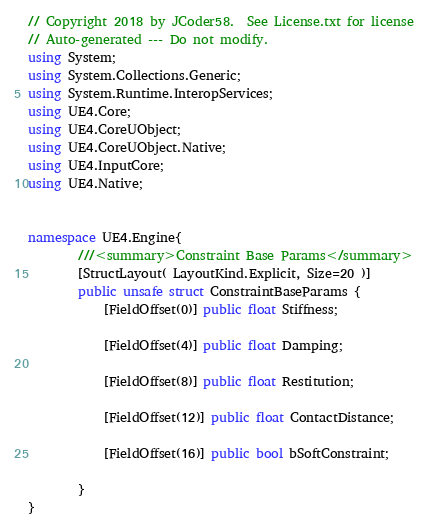<code> <loc_0><loc_0><loc_500><loc_500><_C#_>// Copyright 2018 by JCoder58.  See License.txt for license
// Auto-generated --- Do not modify.
using System;
using System.Collections.Generic;
using System.Runtime.InteropServices;
using UE4.Core;
using UE4.CoreUObject;
using UE4.CoreUObject.Native;
using UE4.InputCore;
using UE4.Native;


namespace UE4.Engine{
        ///<summary>Constraint Base Params</summary>
        [StructLayout( LayoutKind.Explicit, Size=20 )]
        public unsafe struct ConstraintBaseParams {
            [FieldOffset(0)] public float Stiffness;

            [FieldOffset(4)] public float Damping;

            [FieldOffset(8)] public float Restitution;

            [FieldOffset(12)] public float ContactDistance;

            [FieldOffset(16)] public bool bSoftConstraint;

        }
}
</code> 